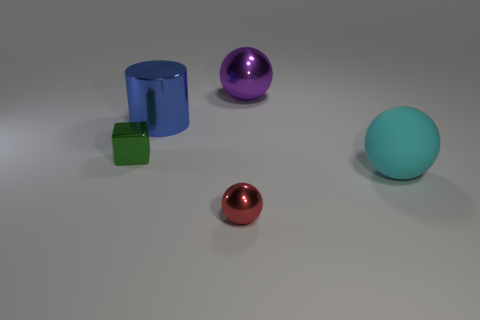Add 4 small objects. How many objects exist? 9 Subtract all spheres. How many objects are left? 2 Add 1 blue things. How many blue things are left? 2 Add 5 big matte spheres. How many big matte spheres exist? 6 Subtract 0 yellow spheres. How many objects are left? 5 Subtract all red objects. Subtract all red rubber cubes. How many objects are left? 4 